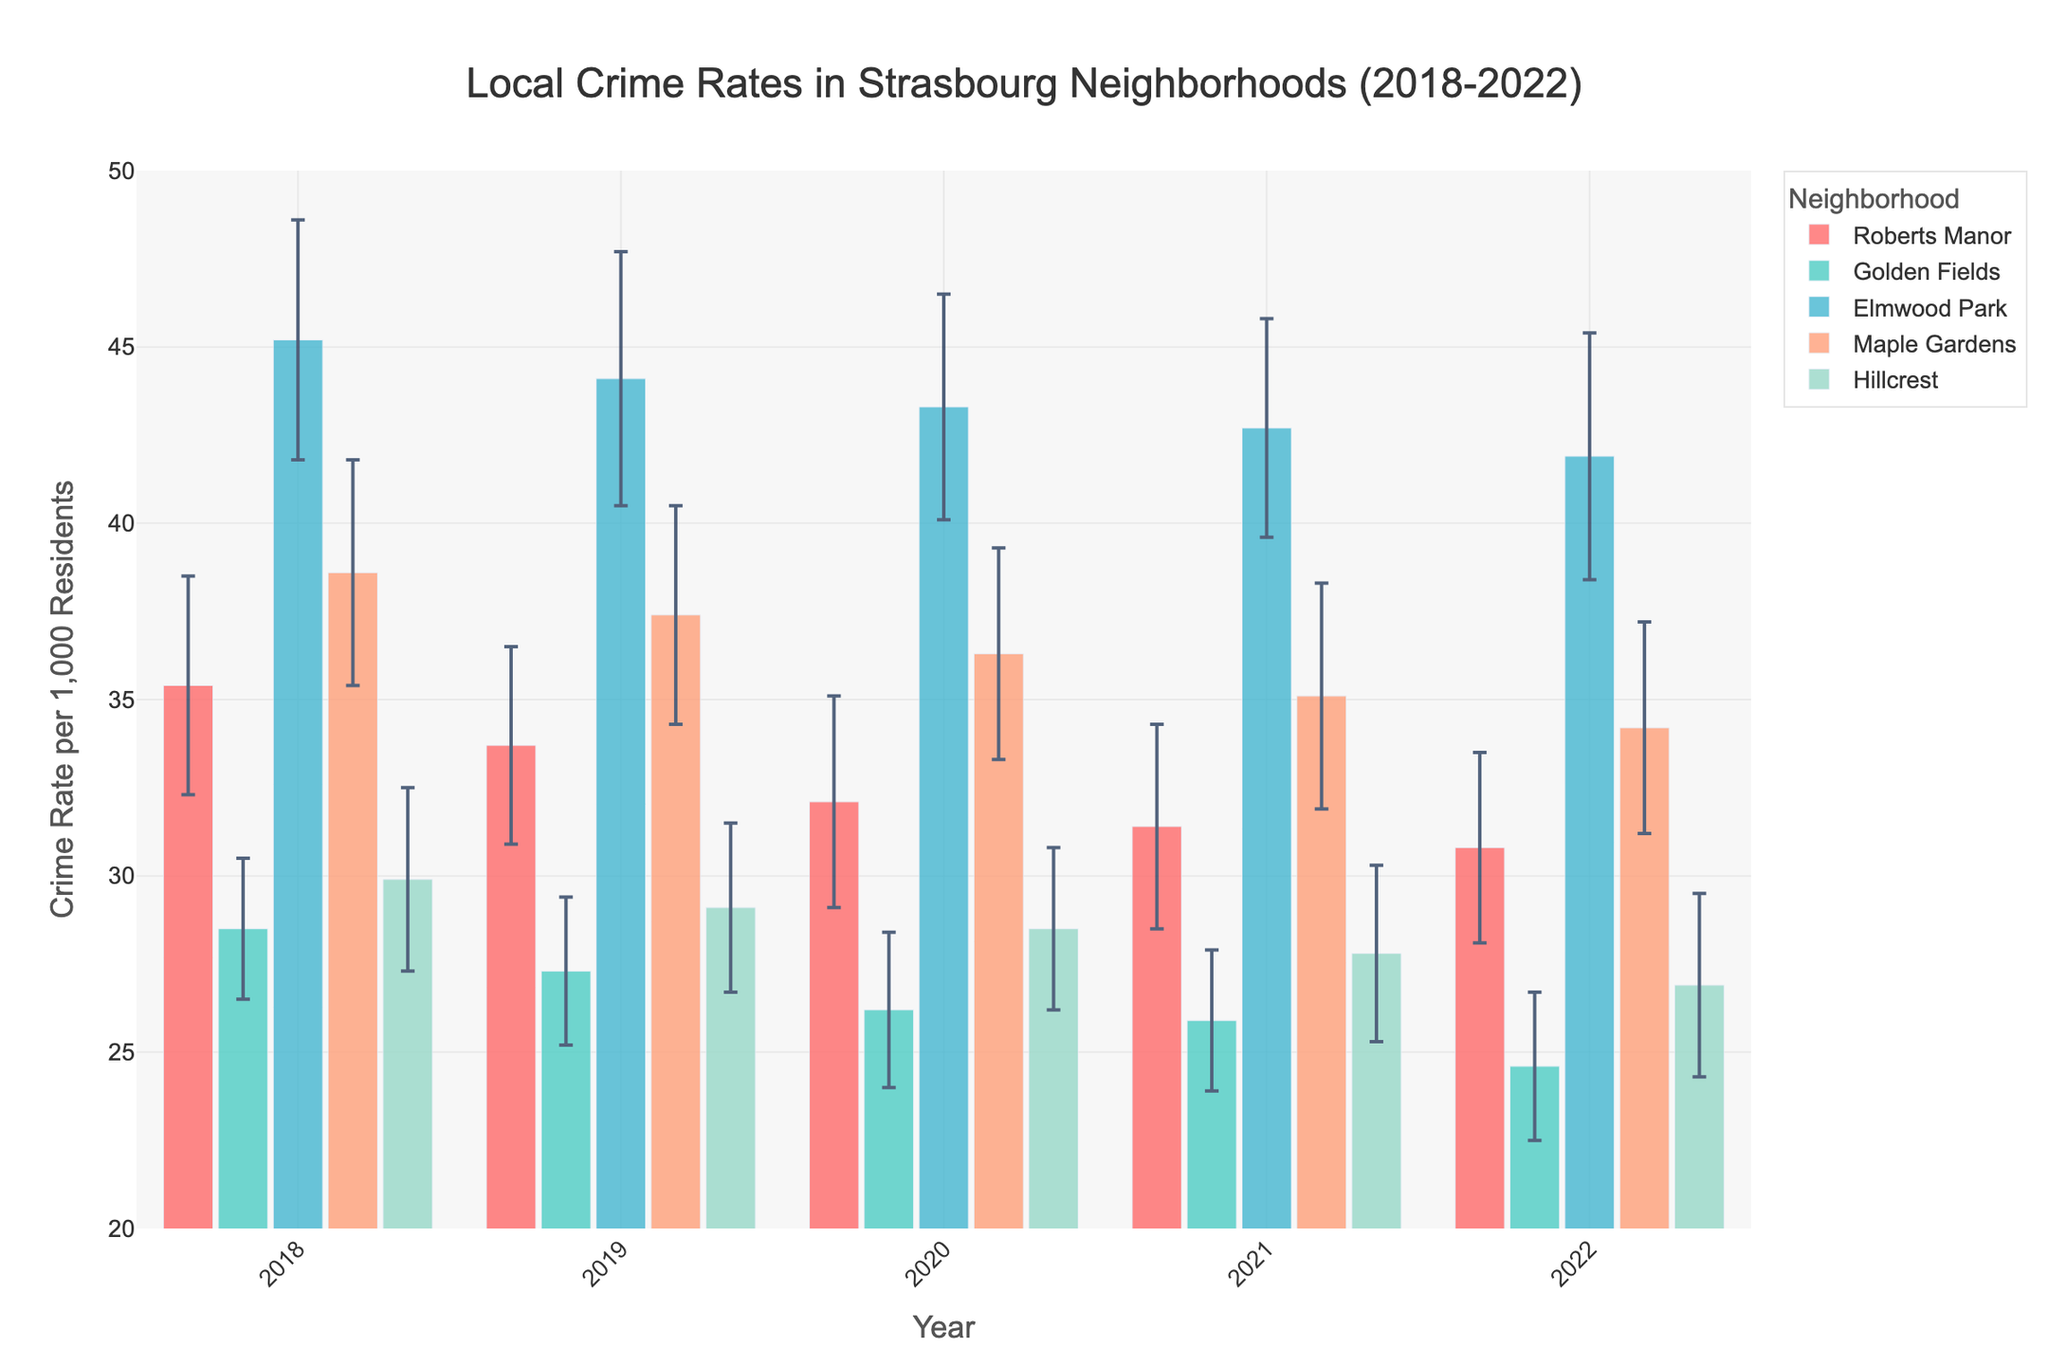What is the title of the figure? The title is usually located at the top of the figure. For this plot, it is centered and clearly labeled.
Answer: Local Crime Rates in Strasbourg Neighborhoods (2018-2022) Which neighborhood had the highest crime rate in 2022? By looking at the bars for the year 2022, we can compare the heights of the bars for each neighborhood. The neighborhood with the tallest bar has the highest crime rate.
Answer: Elmwood Park What is the range of the y-axis in this figure? The y-axis range is indicated by the lowest and highest values on the y-axis. The minimum and maximum values can be read from the axis directly.
Answer: 20 to 50 How does the crime rate trend over the years in Roberts Manor? To determine the trend, we observe the heights of the bars for Roberts Manor from 2018 to 2022 and note whether they increase, decrease, or remain constant.
Answer: Decreasing trend What is the average crime rate of Golden Fields over the five years? Calculate the average by summing up the crime rates for Golden Fields from 2018 to 2022 and dividing by the number of years (5). The detailed calculation is (28.5 + 27.3 + 26.2 + 25.9 + 24.6) / 5 = 132.5 / 5 = 26.5.
Answer: 26.5 Which neighborhood showed the smallest margin of error in 2021? We compare the error bars' lengths for each neighborhood in 2021 and identify the neighborhood with the shortest error bar.
Answer: Golden Fields Compare the crime rates of Elmwood Park and Maple Gardens in 2020. Which is higher and by how much? Look at the bar heights for 2020 for both neighborhoods. Subtract the crime rate of Maple Gardens from Elmwood Park to find the difference. Elmwood Park: 43.3, Maple Gardens: 36.3, Difference: 43.3 - 36.3 = 7.0.
Answer: Elmwood Park, 7.0 How consistent are the crime rates in Hillcrest from 2018 to 2022? To evaluate consistency, observe the changes in bar heights for Hillcrest over the years. A small variation in heights indicates high consistency.
Answer: Fairly consistent with a slight decrease Which year had the lowest overall crime rate across all neighborhoods? Examine the bars for all neighborhoods each year and sum the crime rates. Compare the totals for each year to find the lowest one. Adding up the rates for each year: 2018: 35.4+28.5+45.2+38.6+29.9 = 177.6,  2019: 33.7+27.3+44.1+37.4+29.1 = 171.6,  2020: 32.1+26.2+43.3+36.3+28.5 = 166.4,  2021: 31.4+25.9+42.7+35.1+27.8 = 162.9,  2022: 30.8+24.6+41.9+34.2+26.9 = 158.4.
Answer: 2022 What is the difference in the crime rate between the highest and lowest neighborhoods in 2021? Identify which neighborhoods have the highest and lowest crime rates in 2021, then subtract the lowest rate from the highest rate. The highest in 2021 is Elmwood Park (42.7) and the lowest is Golden Fields (25.9), so the difference is 42.7 - 25.9 = 16.8.
Answer: 16.8 